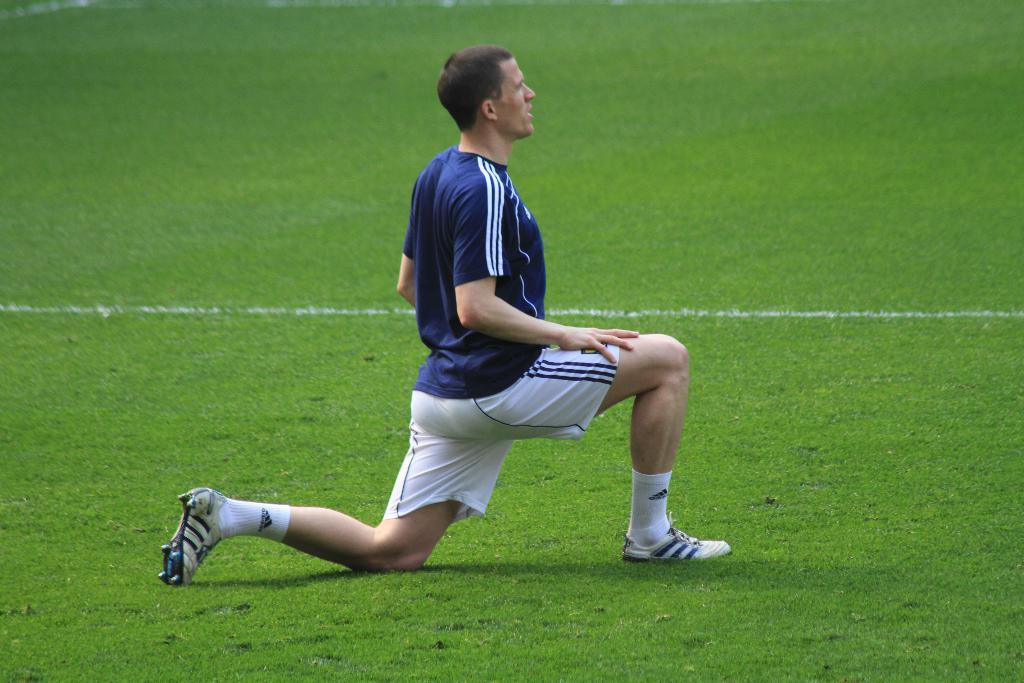Who or what is the main subject in the image? There is a person in the image. What is the person wearing? The person is wearing a blue t-shirt. What position is the person in? The person is on their knees. What type of surface is visible at the bottom of the image? There is grass at the bottom of the image. Is the person's uncle in the image? The facts provided do not mention the presence of an uncle, so we cannot determine if the person's uncle is in the image. 